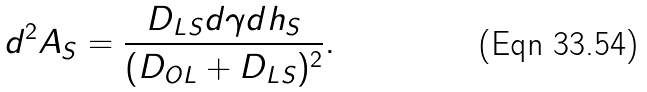<formula> <loc_0><loc_0><loc_500><loc_500>d ^ { 2 } A _ { S } = \frac { D _ { L S } d \gamma d h _ { S } } { ( D _ { O L } + D _ { L S } ) ^ { 2 } } .</formula> 